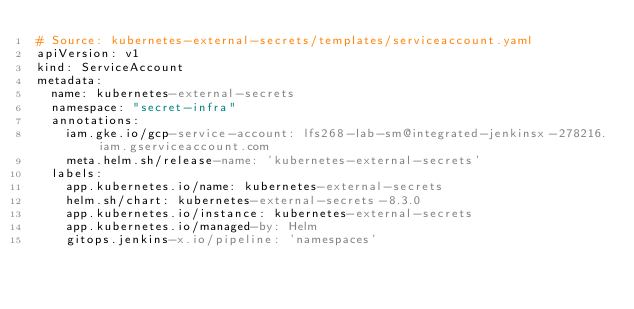Convert code to text. <code><loc_0><loc_0><loc_500><loc_500><_YAML_># Source: kubernetes-external-secrets/templates/serviceaccount.yaml
apiVersion: v1
kind: ServiceAccount
metadata:
  name: kubernetes-external-secrets
  namespace: "secret-infra"
  annotations:
    iam.gke.io/gcp-service-account: lfs268-lab-sm@integrated-jenkinsx-278216.iam.gserviceaccount.com
    meta.helm.sh/release-name: 'kubernetes-external-secrets'
  labels:
    app.kubernetes.io/name: kubernetes-external-secrets
    helm.sh/chart: kubernetes-external-secrets-8.3.0
    app.kubernetes.io/instance: kubernetes-external-secrets
    app.kubernetes.io/managed-by: Helm
    gitops.jenkins-x.io/pipeline: 'namespaces'
</code> 